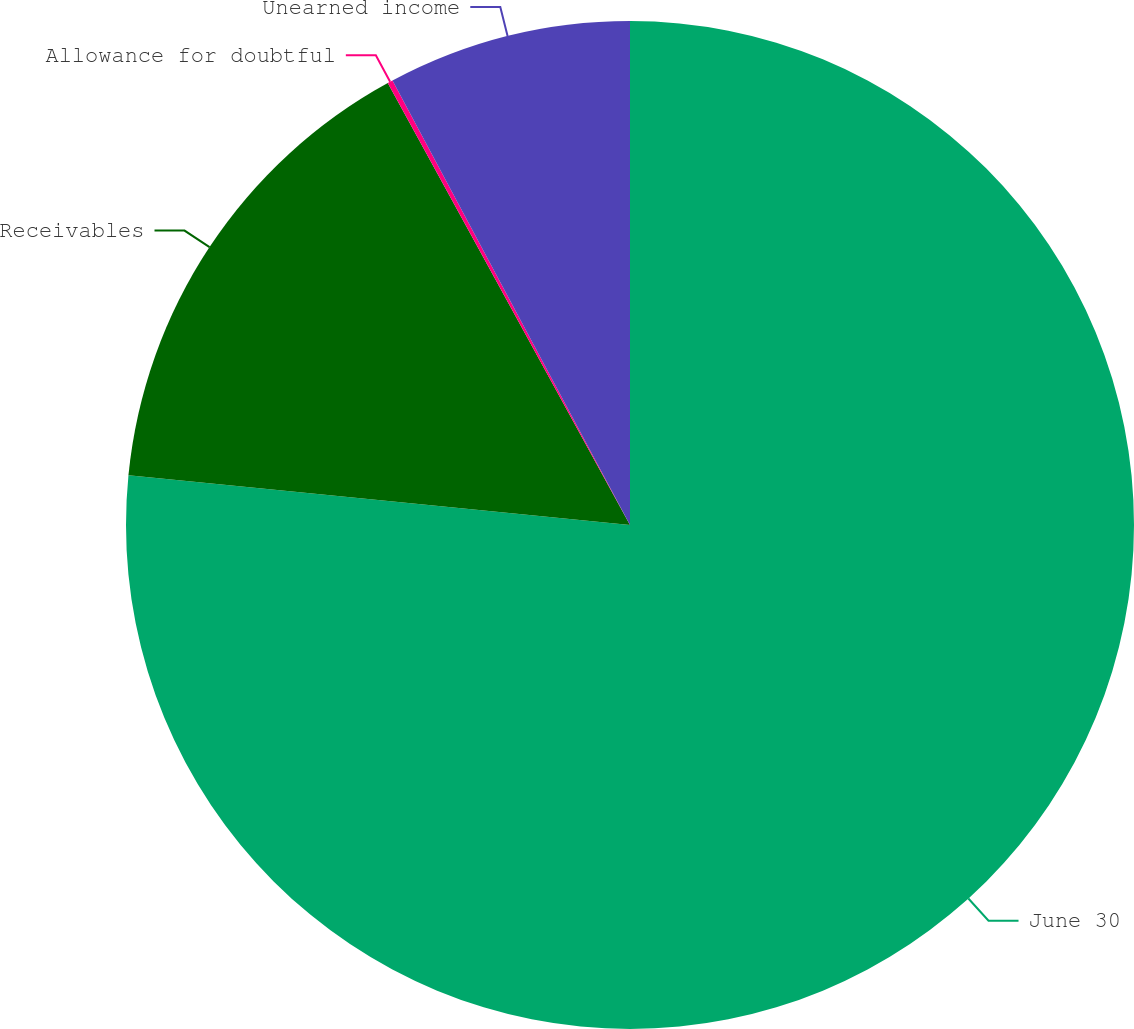Convert chart. <chart><loc_0><loc_0><loc_500><loc_500><pie_chart><fcel>June 30<fcel>Receivables<fcel>Allowance for doubtful<fcel>Unearned income<nl><fcel>76.57%<fcel>15.45%<fcel>0.17%<fcel>7.81%<nl></chart> 